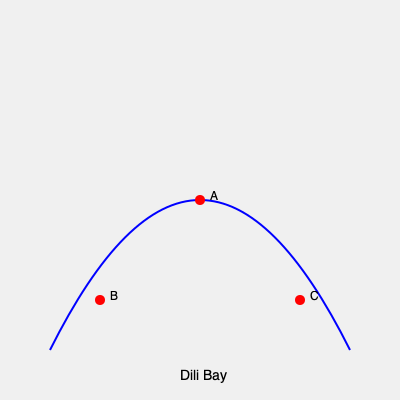Based on the aerial view of Dili, East Timor, which landmark is represented by point A? To identify the landmark at point A, let's analyze the aerial view:

1. The blue curve represents the coastline of Dili Bay.
2. Point A is located at the center of the image, slightly inland from the coast.
3. Given our experience in East Timor, we know that the most significant landmark in this central location is Cristo Rei, the large statue of Jesus Christ.
4. Point B, being closer to the western part of the bay, likely represents the Dili port area.
5. Point C, on the eastern side, could be the Areia Branca beach area.

The central location and prominence of point A in this aerial view strongly indicate that it represents the Cristo Rei statue, a key landmark in Dili that we would have been familiar with during our mission.
Answer: Cristo Rei statue 